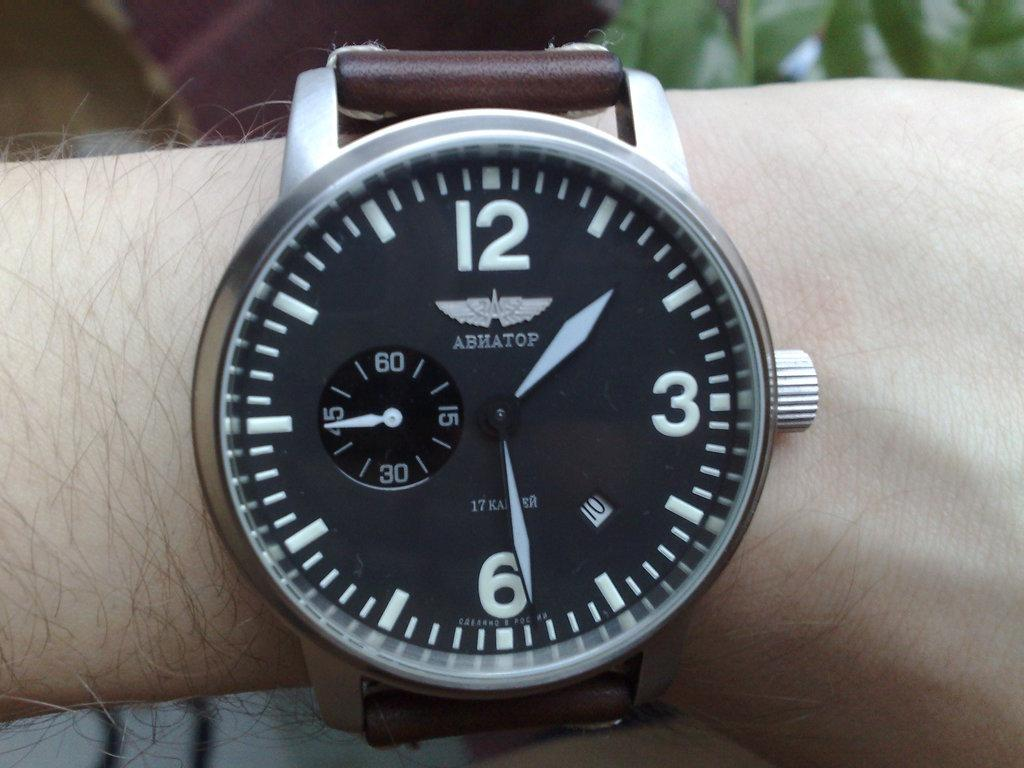Provide a one-sentence caption for the provided image. An ABHATOP wristwatch shows the time to be 1:29. 